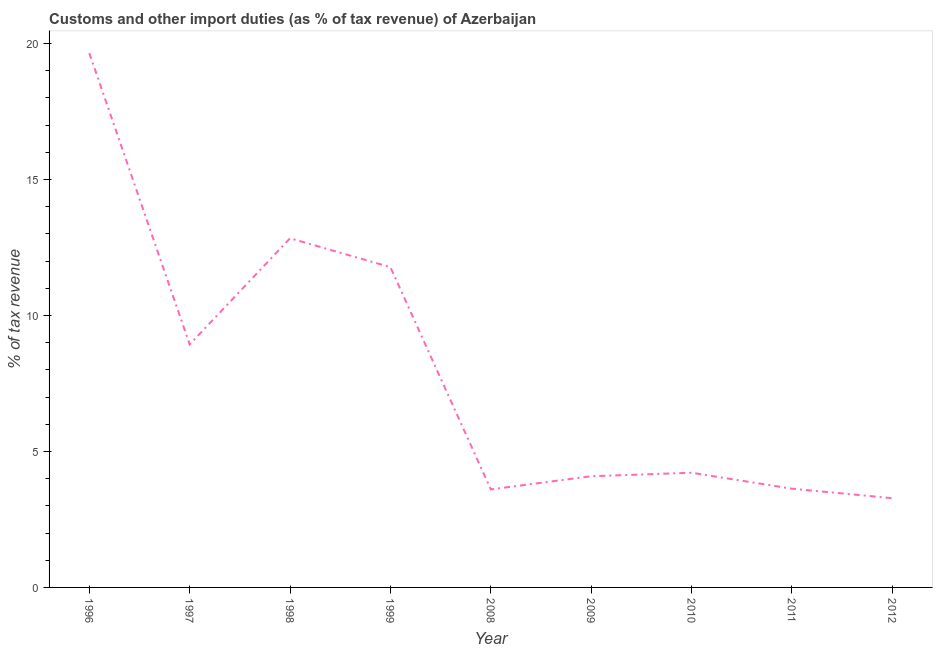What is the customs and other import duties in 1998?
Your response must be concise. 12.84. Across all years, what is the maximum customs and other import duties?
Offer a very short reply. 19.65. Across all years, what is the minimum customs and other import duties?
Your answer should be compact. 3.28. In which year was the customs and other import duties maximum?
Your answer should be compact. 1996. In which year was the customs and other import duties minimum?
Make the answer very short. 2012. What is the sum of the customs and other import duties?
Your answer should be very brief. 72.01. What is the difference between the customs and other import duties in 2008 and 2011?
Provide a short and direct response. -0.03. What is the average customs and other import duties per year?
Offer a very short reply. 8. What is the median customs and other import duties?
Make the answer very short. 4.22. In how many years, is the customs and other import duties greater than 8 %?
Keep it short and to the point. 4. Do a majority of the years between 1996 and 2012 (inclusive) have customs and other import duties greater than 9 %?
Your answer should be compact. No. What is the ratio of the customs and other import duties in 2008 to that in 2010?
Offer a very short reply. 0.85. Is the customs and other import duties in 1996 less than that in 2008?
Your answer should be compact. No. What is the difference between the highest and the second highest customs and other import duties?
Provide a succinct answer. 6.81. What is the difference between the highest and the lowest customs and other import duties?
Make the answer very short. 16.36. In how many years, is the customs and other import duties greater than the average customs and other import duties taken over all years?
Offer a very short reply. 4. How many lines are there?
Make the answer very short. 1. How many years are there in the graph?
Your response must be concise. 9. What is the difference between two consecutive major ticks on the Y-axis?
Your answer should be compact. 5. Are the values on the major ticks of Y-axis written in scientific E-notation?
Give a very brief answer. No. Does the graph contain any zero values?
Your response must be concise. No. Does the graph contain grids?
Ensure brevity in your answer.  No. What is the title of the graph?
Ensure brevity in your answer.  Customs and other import duties (as % of tax revenue) of Azerbaijan. What is the label or title of the Y-axis?
Provide a short and direct response. % of tax revenue. What is the % of tax revenue in 1996?
Make the answer very short. 19.65. What is the % of tax revenue in 1997?
Give a very brief answer. 8.93. What is the % of tax revenue in 1998?
Offer a very short reply. 12.84. What is the % of tax revenue in 1999?
Your response must be concise. 11.77. What is the % of tax revenue of 2008?
Give a very brief answer. 3.6. What is the % of tax revenue in 2009?
Your answer should be compact. 4.09. What is the % of tax revenue in 2010?
Your answer should be very brief. 4.22. What is the % of tax revenue of 2011?
Keep it short and to the point. 3.63. What is the % of tax revenue in 2012?
Make the answer very short. 3.28. What is the difference between the % of tax revenue in 1996 and 1997?
Ensure brevity in your answer.  10.71. What is the difference between the % of tax revenue in 1996 and 1998?
Ensure brevity in your answer.  6.81. What is the difference between the % of tax revenue in 1996 and 1999?
Your answer should be compact. 7.87. What is the difference between the % of tax revenue in 1996 and 2008?
Provide a short and direct response. 16.04. What is the difference between the % of tax revenue in 1996 and 2009?
Your answer should be compact. 15.56. What is the difference between the % of tax revenue in 1996 and 2010?
Provide a short and direct response. 15.43. What is the difference between the % of tax revenue in 1996 and 2011?
Your answer should be very brief. 16.02. What is the difference between the % of tax revenue in 1996 and 2012?
Offer a very short reply. 16.36. What is the difference between the % of tax revenue in 1997 and 1998?
Your answer should be very brief. -3.9. What is the difference between the % of tax revenue in 1997 and 1999?
Your response must be concise. -2.84. What is the difference between the % of tax revenue in 1997 and 2008?
Provide a succinct answer. 5.33. What is the difference between the % of tax revenue in 1997 and 2009?
Give a very brief answer. 4.84. What is the difference between the % of tax revenue in 1997 and 2010?
Provide a succinct answer. 4.72. What is the difference between the % of tax revenue in 1997 and 2011?
Your answer should be compact. 5.3. What is the difference between the % of tax revenue in 1997 and 2012?
Provide a succinct answer. 5.65. What is the difference between the % of tax revenue in 1998 and 1999?
Your response must be concise. 1.06. What is the difference between the % of tax revenue in 1998 and 2008?
Give a very brief answer. 9.23. What is the difference between the % of tax revenue in 1998 and 2009?
Make the answer very short. 8.75. What is the difference between the % of tax revenue in 1998 and 2010?
Your answer should be compact. 8.62. What is the difference between the % of tax revenue in 1998 and 2011?
Give a very brief answer. 9.21. What is the difference between the % of tax revenue in 1998 and 2012?
Provide a short and direct response. 9.56. What is the difference between the % of tax revenue in 1999 and 2008?
Ensure brevity in your answer.  8.17. What is the difference between the % of tax revenue in 1999 and 2009?
Give a very brief answer. 7.69. What is the difference between the % of tax revenue in 1999 and 2010?
Provide a succinct answer. 7.56. What is the difference between the % of tax revenue in 1999 and 2011?
Provide a succinct answer. 8.14. What is the difference between the % of tax revenue in 1999 and 2012?
Ensure brevity in your answer.  8.49. What is the difference between the % of tax revenue in 2008 and 2009?
Offer a very short reply. -0.48. What is the difference between the % of tax revenue in 2008 and 2010?
Your answer should be very brief. -0.61. What is the difference between the % of tax revenue in 2008 and 2011?
Ensure brevity in your answer.  -0.03. What is the difference between the % of tax revenue in 2008 and 2012?
Your response must be concise. 0.32. What is the difference between the % of tax revenue in 2009 and 2010?
Keep it short and to the point. -0.13. What is the difference between the % of tax revenue in 2009 and 2011?
Make the answer very short. 0.46. What is the difference between the % of tax revenue in 2009 and 2012?
Provide a short and direct response. 0.81. What is the difference between the % of tax revenue in 2010 and 2011?
Your answer should be very brief. 0.59. What is the difference between the % of tax revenue in 2010 and 2012?
Your answer should be very brief. 0.94. What is the difference between the % of tax revenue in 2011 and 2012?
Provide a succinct answer. 0.35. What is the ratio of the % of tax revenue in 1996 to that in 1997?
Offer a very short reply. 2.2. What is the ratio of the % of tax revenue in 1996 to that in 1998?
Offer a terse response. 1.53. What is the ratio of the % of tax revenue in 1996 to that in 1999?
Keep it short and to the point. 1.67. What is the ratio of the % of tax revenue in 1996 to that in 2008?
Provide a succinct answer. 5.45. What is the ratio of the % of tax revenue in 1996 to that in 2009?
Your response must be concise. 4.81. What is the ratio of the % of tax revenue in 1996 to that in 2010?
Ensure brevity in your answer.  4.66. What is the ratio of the % of tax revenue in 1996 to that in 2011?
Your answer should be very brief. 5.41. What is the ratio of the % of tax revenue in 1996 to that in 2012?
Your answer should be very brief. 5.99. What is the ratio of the % of tax revenue in 1997 to that in 1998?
Ensure brevity in your answer.  0.7. What is the ratio of the % of tax revenue in 1997 to that in 1999?
Your answer should be compact. 0.76. What is the ratio of the % of tax revenue in 1997 to that in 2008?
Offer a terse response. 2.48. What is the ratio of the % of tax revenue in 1997 to that in 2009?
Make the answer very short. 2.19. What is the ratio of the % of tax revenue in 1997 to that in 2010?
Make the answer very short. 2.12. What is the ratio of the % of tax revenue in 1997 to that in 2011?
Provide a short and direct response. 2.46. What is the ratio of the % of tax revenue in 1997 to that in 2012?
Keep it short and to the point. 2.72. What is the ratio of the % of tax revenue in 1998 to that in 1999?
Offer a terse response. 1.09. What is the ratio of the % of tax revenue in 1998 to that in 2008?
Your answer should be very brief. 3.56. What is the ratio of the % of tax revenue in 1998 to that in 2009?
Make the answer very short. 3.14. What is the ratio of the % of tax revenue in 1998 to that in 2010?
Ensure brevity in your answer.  3.04. What is the ratio of the % of tax revenue in 1998 to that in 2011?
Offer a very short reply. 3.54. What is the ratio of the % of tax revenue in 1998 to that in 2012?
Provide a succinct answer. 3.91. What is the ratio of the % of tax revenue in 1999 to that in 2008?
Ensure brevity in your answer.  3.27. What is the ratio of the % of tax revenue in 1999 to that in 2009?
Your answer should be compact. 2.88. What is the ratio of the % of tax revenue in 1999 to that in 2010?
Make the answer very short. 2.79. What is the ratio of the % of tax revenue in 1999 to that in 2011?
Provide a short and direct response. 3.24. What is the ratio of the % of tax revenue in 1999 to that in 2012?
Offer a very short reply. 3.59. What is the ratio of the % of tax revenue in 2008 to that in 2009?
Make the answer very short. 0.88. What is the ratio of the % of tax revenue in 2008 to that in 2010?
Give a very brief answer. 0.85. What is the ratio of the % of tax revenue in 2008 to that in 2012?
Provide a short and direct response. 1.1. What is the ratio of the % of tax revenue in 2009 to that in 2011?
Your answer should be compact. 1.13. What is the ratio of the % of tax revenue in 2009 to that in 2012?
Offer a very short reply. 1.25. What is the ratio of the % of tax revenue in 2010 to that in 2011?
Your response must be concise. 1.16. What is the ratio of the % of tax revenue in 2010 to that in 2012?
Provide a short and direct response. 1.28. What is the ratio of the % of tax revenue in 2011 to that in 2012?
Your answer should be very brief. 1.11. 